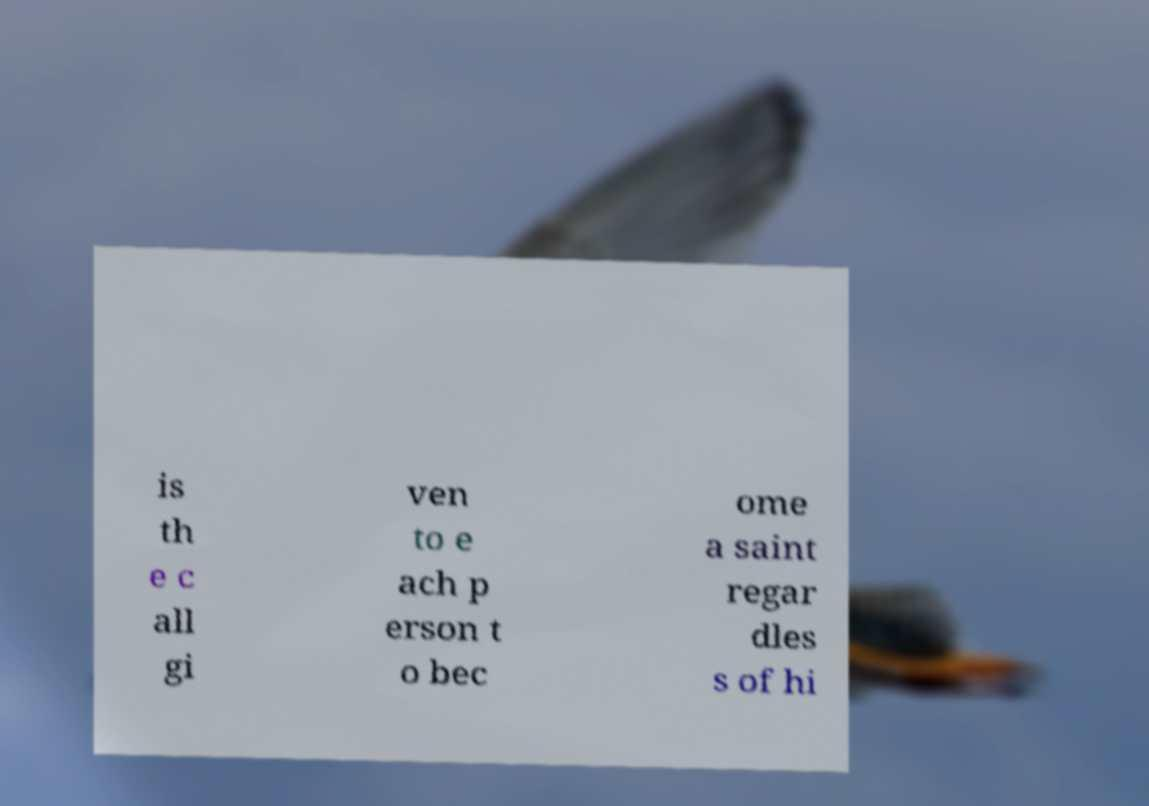There's text embedded in this image that I need extracted. Can you transcribe it verbatim? is th e c all gi ven to e ach p erson t o bec ome a saint regar dles s of hi 